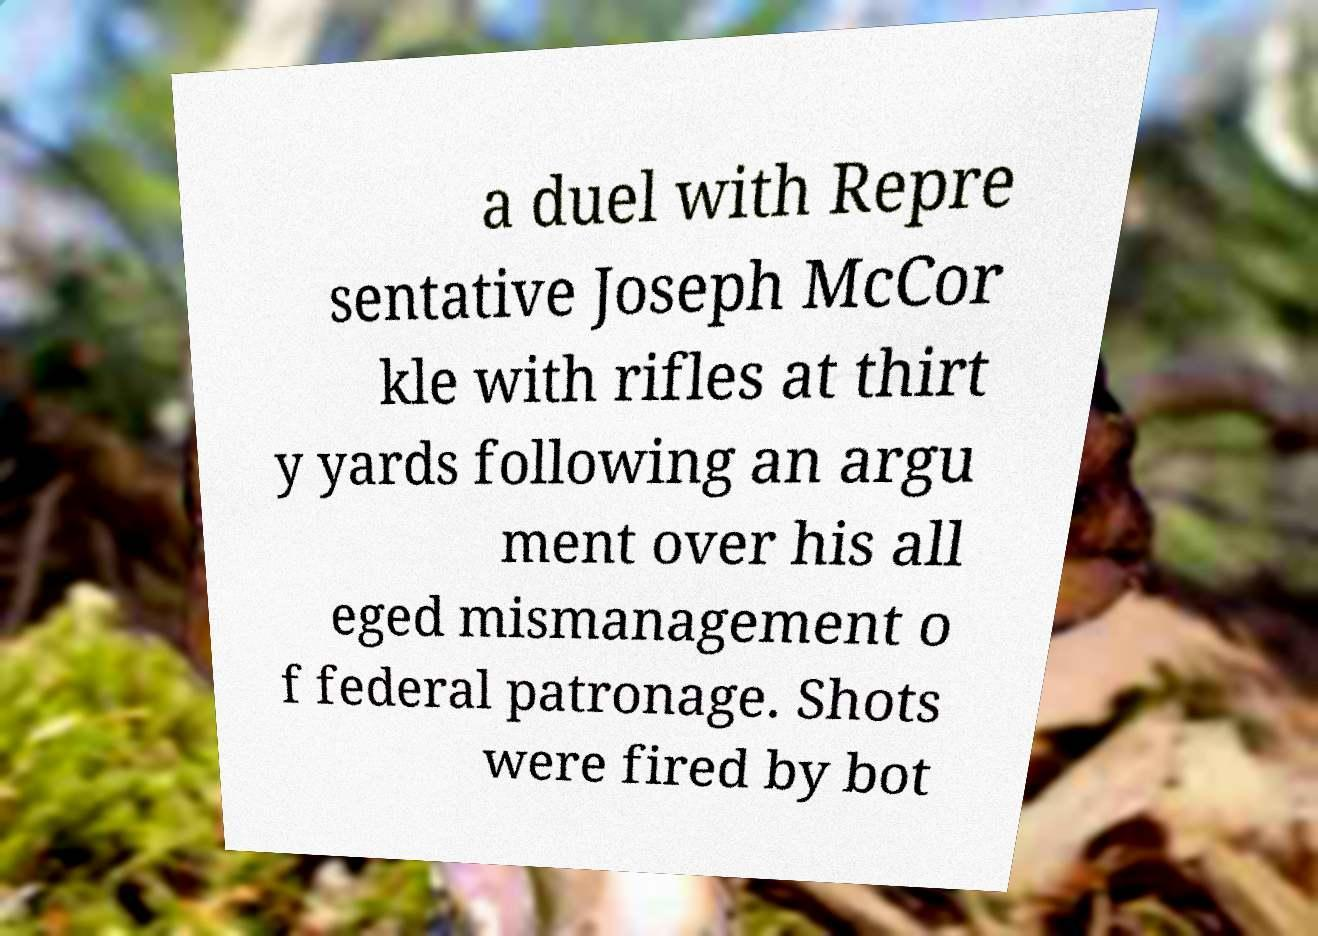Can you accurately transcribe the text from the provided image for me? a duel with Repre sentative Joseph McCor kle with rifles at thirt y yards following an argu ment over his all eged mismanagement o f federal patronage. Shots were fired by bot 